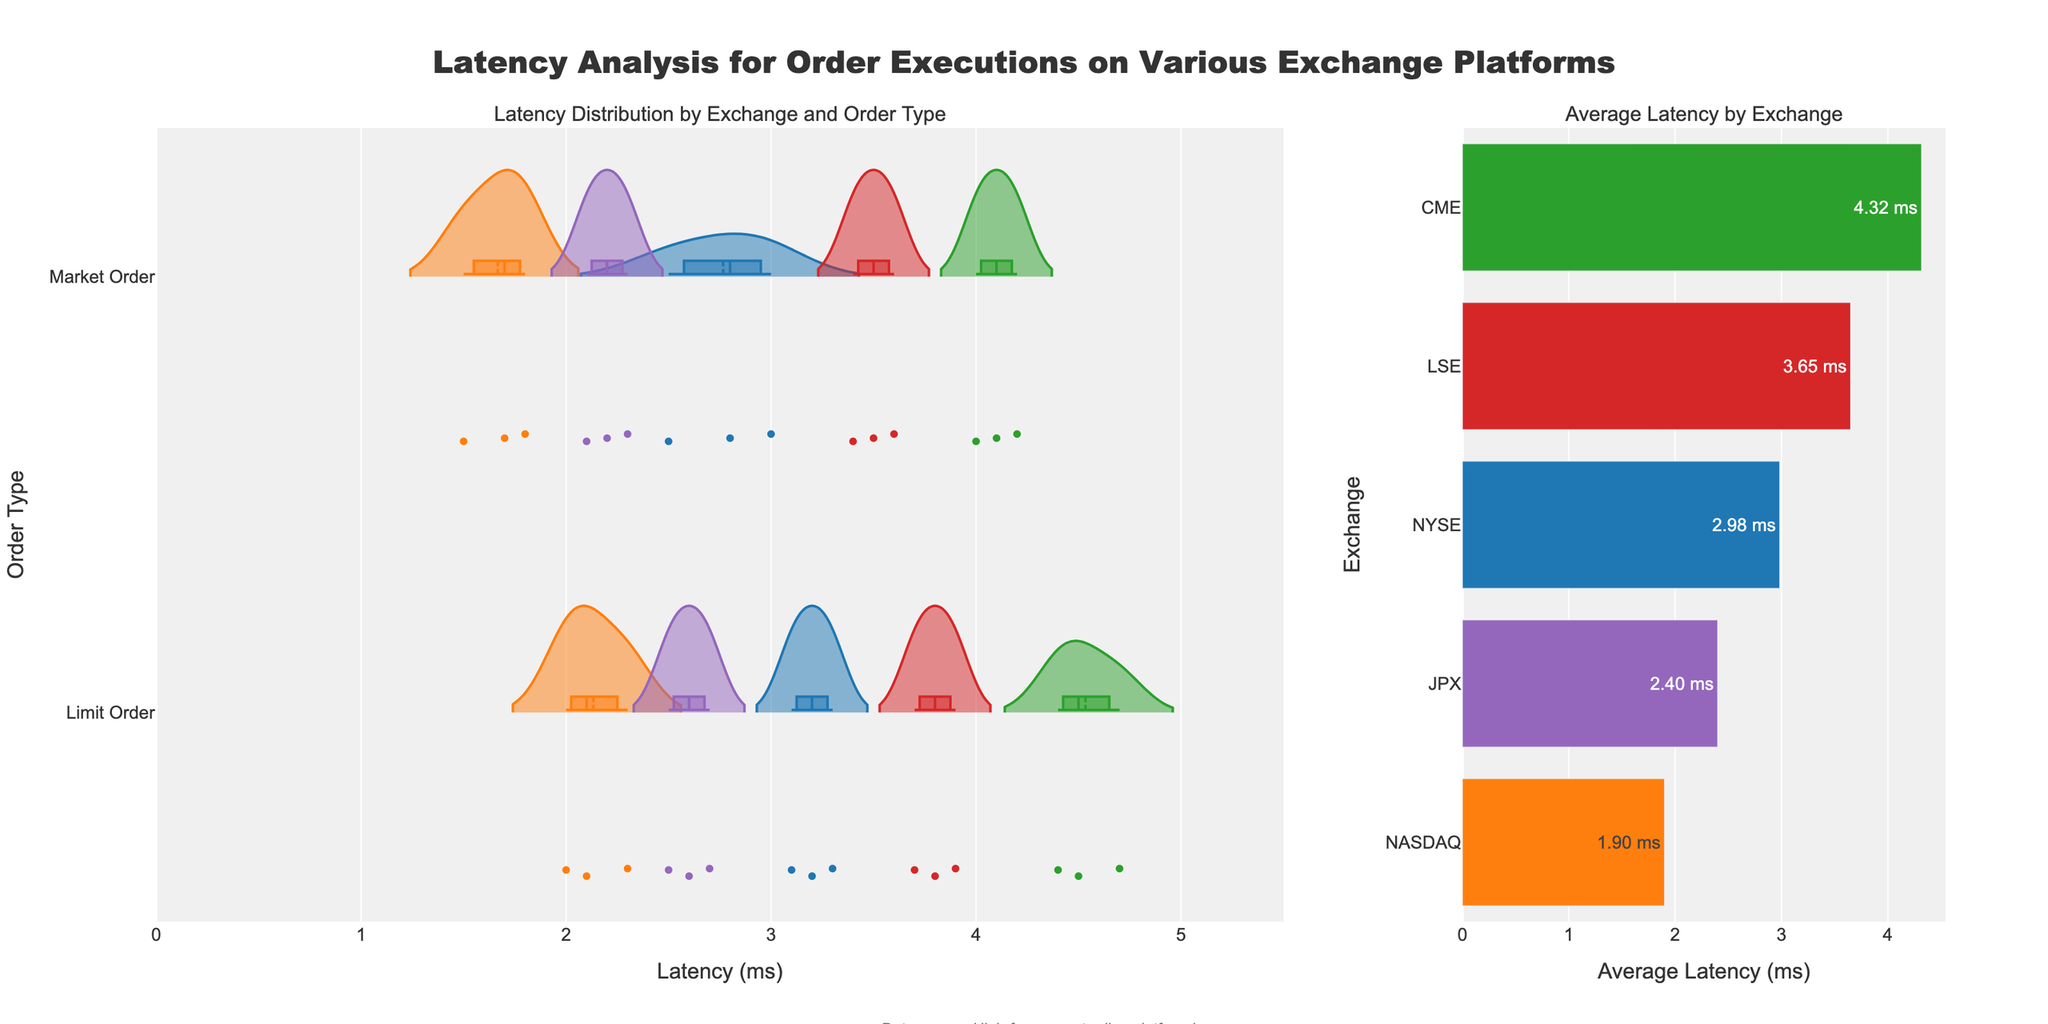what is the chart's title? The title is located at the top of the figure and reads "Latency Analysis for Order Executions on Various Exchange Platforms."
Answer: Latency Analysis for Order Executions on Various Exchange Platforms Which exchange has the highest average latency? The bar plot on the right shows the average latencies of different exchanges. CME has the highest bar, indicating the highest average latency.
Answer: CME How does the average latency of NYSE compare to NASDAQ? The bar plot shows that NYSE has a higher average latency compared to NASDAQ as the bar for NYSE is longer than that for NASDAQ.
Answer: NYSE has higher average latency What is the range of latency for market orders on NYSE? On the violin plot, the range for NYSE market orders can be observed from the bottom to the top of the violin. It spans from 2.5 ms to 3.0 ms.
Answer: 2.5 ms to 3.0 ms Which order type on JPX has more spread in latency? By observing the width of the violins for JPX, the limit order has a wider spread compared to the market order, which suggests more spread in latency.
Answer: Limit order How does the shape of the violin plots differ between LSE and CME for limit orders? For limit orders, the violin plot for LSE and CME can be compared directly within the plot. LSE's violin plot is less spread out compared to CME, indicating more uniform latency for LSE.
Answer: LSE has less spread What is the mean latency for NASDAQ limit orders? The mean latency line for NASDAQ limit orders appears at approximately 2.1 ms in the violin plot segment for NASDAQ limit orders.
Answer: 2.1 ms Compare the latency distribution for market orders across all exchanges. By looking at the violin plots corresponding to market orders, the distributions can be compared. CME has the widest spread and highest latencies, while NASDAQ's data shows the shortest and least spread out.
Answer: CME > LSE > NYSE > JPX > NASDAQ Are the latency distributions for limit orders more uniform than market orders across exchanges? By observing the violin plots, limit orders generally show more uniform and consistent distributions across exchanges compared to market orders, which often show more variation.
Answer: Yes Which exchange has the smallest difference in average latency between market and limit orders? By comparing the proximity of the mean lines and violin plot shapes for market and limit orders for each exchange, NASDAQ shows the smallest difference in average latencies between the two order types.
Answer: NASDAQ 